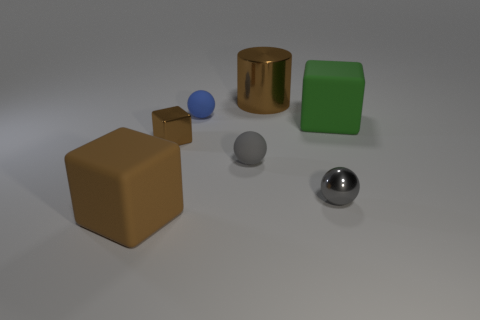Add 1 tiny blue balls. How many objects exist? 8 Subtract all blocks. How many objects are left? 4 Subtract 0 purple cylinders. How many objects are left? 7 Subtract all large matte things. Subtract all blue balls. How many objects are left? 4 Add 4 big green matte things. How many big green matte things are left? 5 Add 5 big cylinders. How many big cylinders exist? 6 